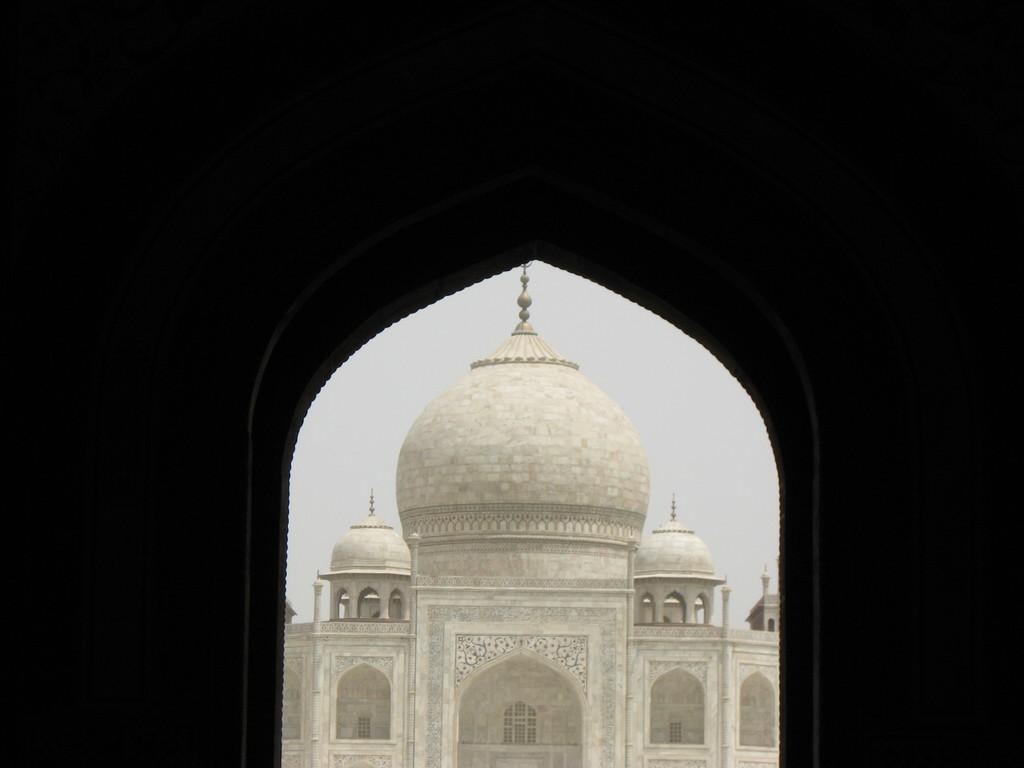What type of structure is present in the image? There is a building in the image. What material is the building made of? The building is made with marbles. What can be seen in the background of the image? The sky is visible in the background of the image. What type of chain is hanging from the building in the image? There is no chain present in the image; the building is made with marbles. Is there a judge standing next to the building in the image? There is no judge present in the image; it only features a building made with marbles and the sky in the background. 